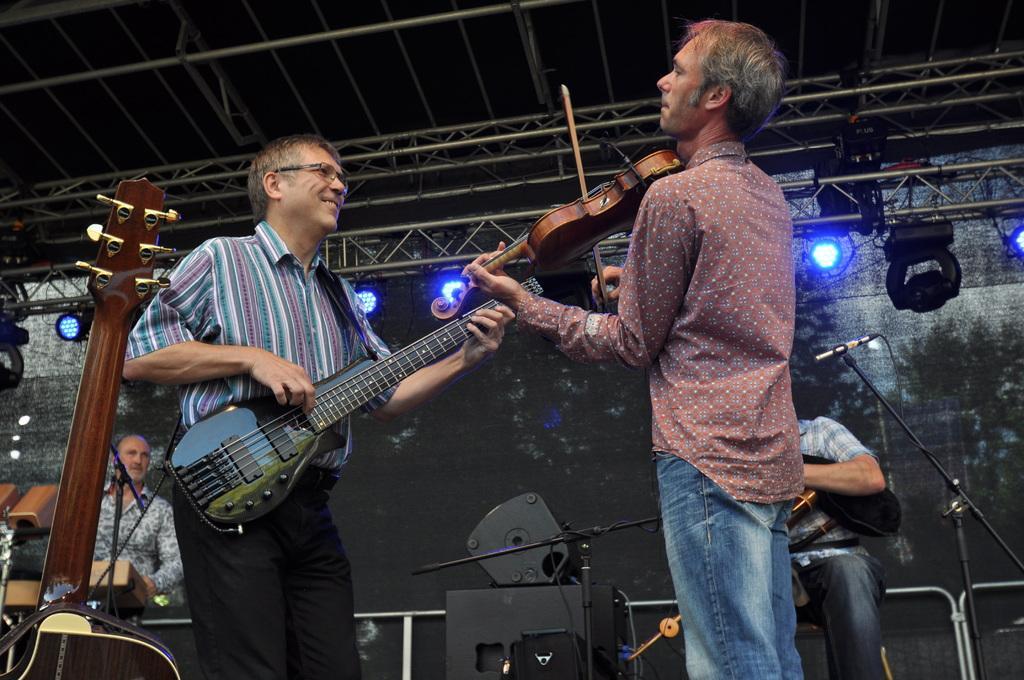In one or two sentences, can you explain what this image depicts? This picture is clicked in a musical concert. Man in pink shirt is holding violin in his hands and playing it. Beside him, man in blue and white shirt is holding guitar his hands and playing it. Behind the, man in white and blue shirt is holding a black bag in his hands. On the left corner, man in white and black shirt is standing and looking this people and in front of him, we see a microphone. On top of the picture, we see the ceiling of that room. 